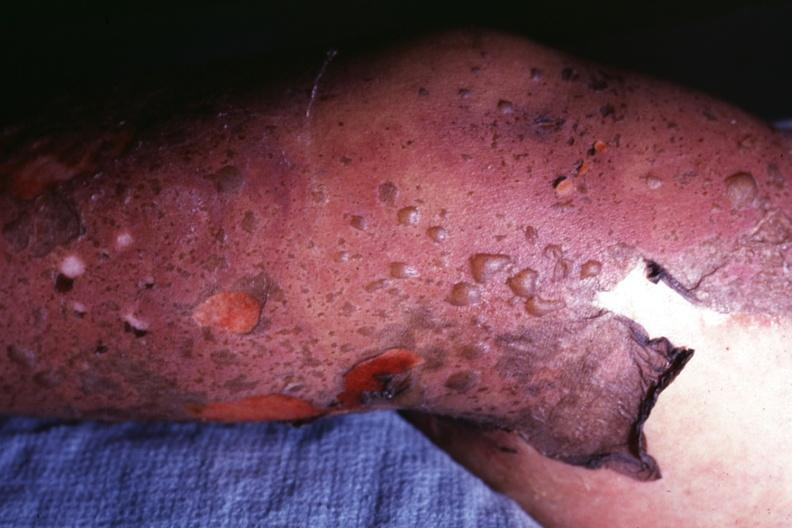does this image show close-up of bullous skin lesions and peeling of skin?
Answer the question using a single word or phrase. Yes 